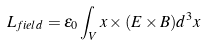Convert formula to latex. <formula><loc_0><loc_0><loc_500><loc_500>L _ { f i e l d } = \epsilon _ { 0 } \int _ { V } x \times ( E \times B ) d ^ { 3 } x</formula> 